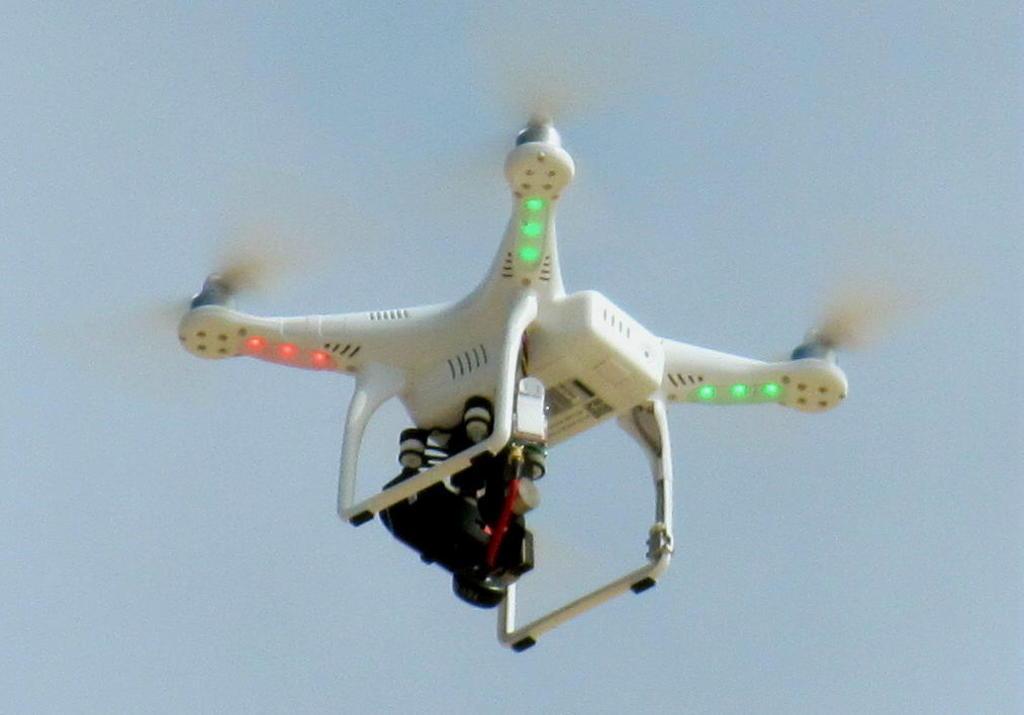Describe this image in one or two sentences. In this picture there is a drone in the center of the image. 